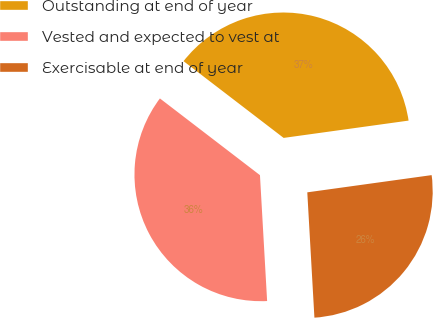Convert chart. <chart><loc_0><loc_0><loc_500><loc_500><pie_chart><fcel>Outstanding at end of year<fcel>Vested and expected to vest at<fcel>Exercisable at end of year<nl><fcel>37.4%<fcel>36.32%<fcel>26.29%<nl></chart> 